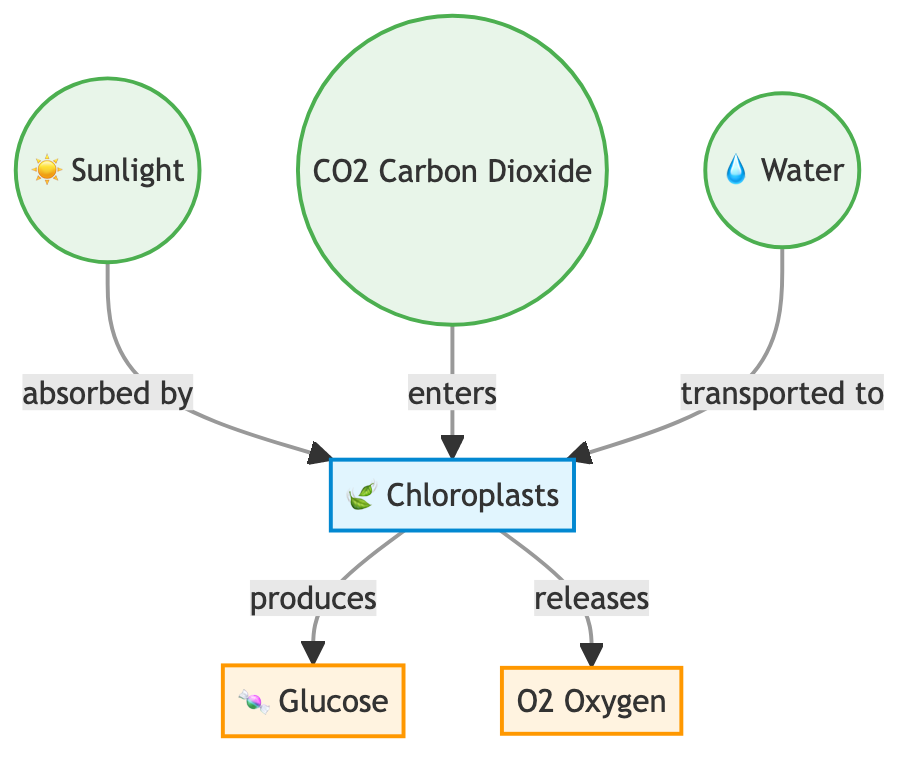What are the inputs to the photosynthesis process? The diagram shows three inputs: sunlight, carbon dioxide, and water. These are the essential components that enter the chloroplasts for the photosynthesis process.
Answer: Sunlight, carbon dioxide, water How many outputs are produced from the chloroplasts? The diagram indicates there are two outputs produced: glucose and oxygen. These are the products of the photosynthesis process after the input materials are processed in the chloroplasts.
Answer: Two What is the role of chloroplasts in photosynthesis? Chloroplasts are indicated as the process nodes that absorb sunlight, take in carbon dioxide, and transport water, ultimately producing glucose and releasing oxygen. This shows that chloroplasts are essential for converting input materials into energy.
Answer: Produces glucose and releases oxygen Which substance enters the chloroplasts along with carbon dioxide? The diagram shows that water is also transported to the chloroplasts, alongside carbon dioxide. This indicates that both are necessary for the process to take place.
Answer: Water What substance is produced alongside glucose in photosynthesis? According to the diagram, oxygen is released alongside glucose as the outcome of the photosynthesis process. This means both are produced during this process.
Answer: Oxygen How is sunlight processed in the diagram? The diagram indicates that sunlight is absorbed by the chloroplasts, which is the initial step in the photosynthesis process. This shows that sunlight is crucial for starting the energy conversion.
Answer: Absorbed by chloroplasts What do the inputs of sunlight, carbon dioxide, and water lead to in the photosynthesis process? The inputs lead to the production of glucose and the release of oxygen as outputs. So, the combination of these inputs drives the process that results in these two outputs from the chloroplasts.
Answer: Glucose and oxygen What is the final output of the process in the chloroplasts? The final output that is explicitly mentioned in the diagram is glucose, indicating that it is the main product created during photosynthesis.
Answer: Glucose 